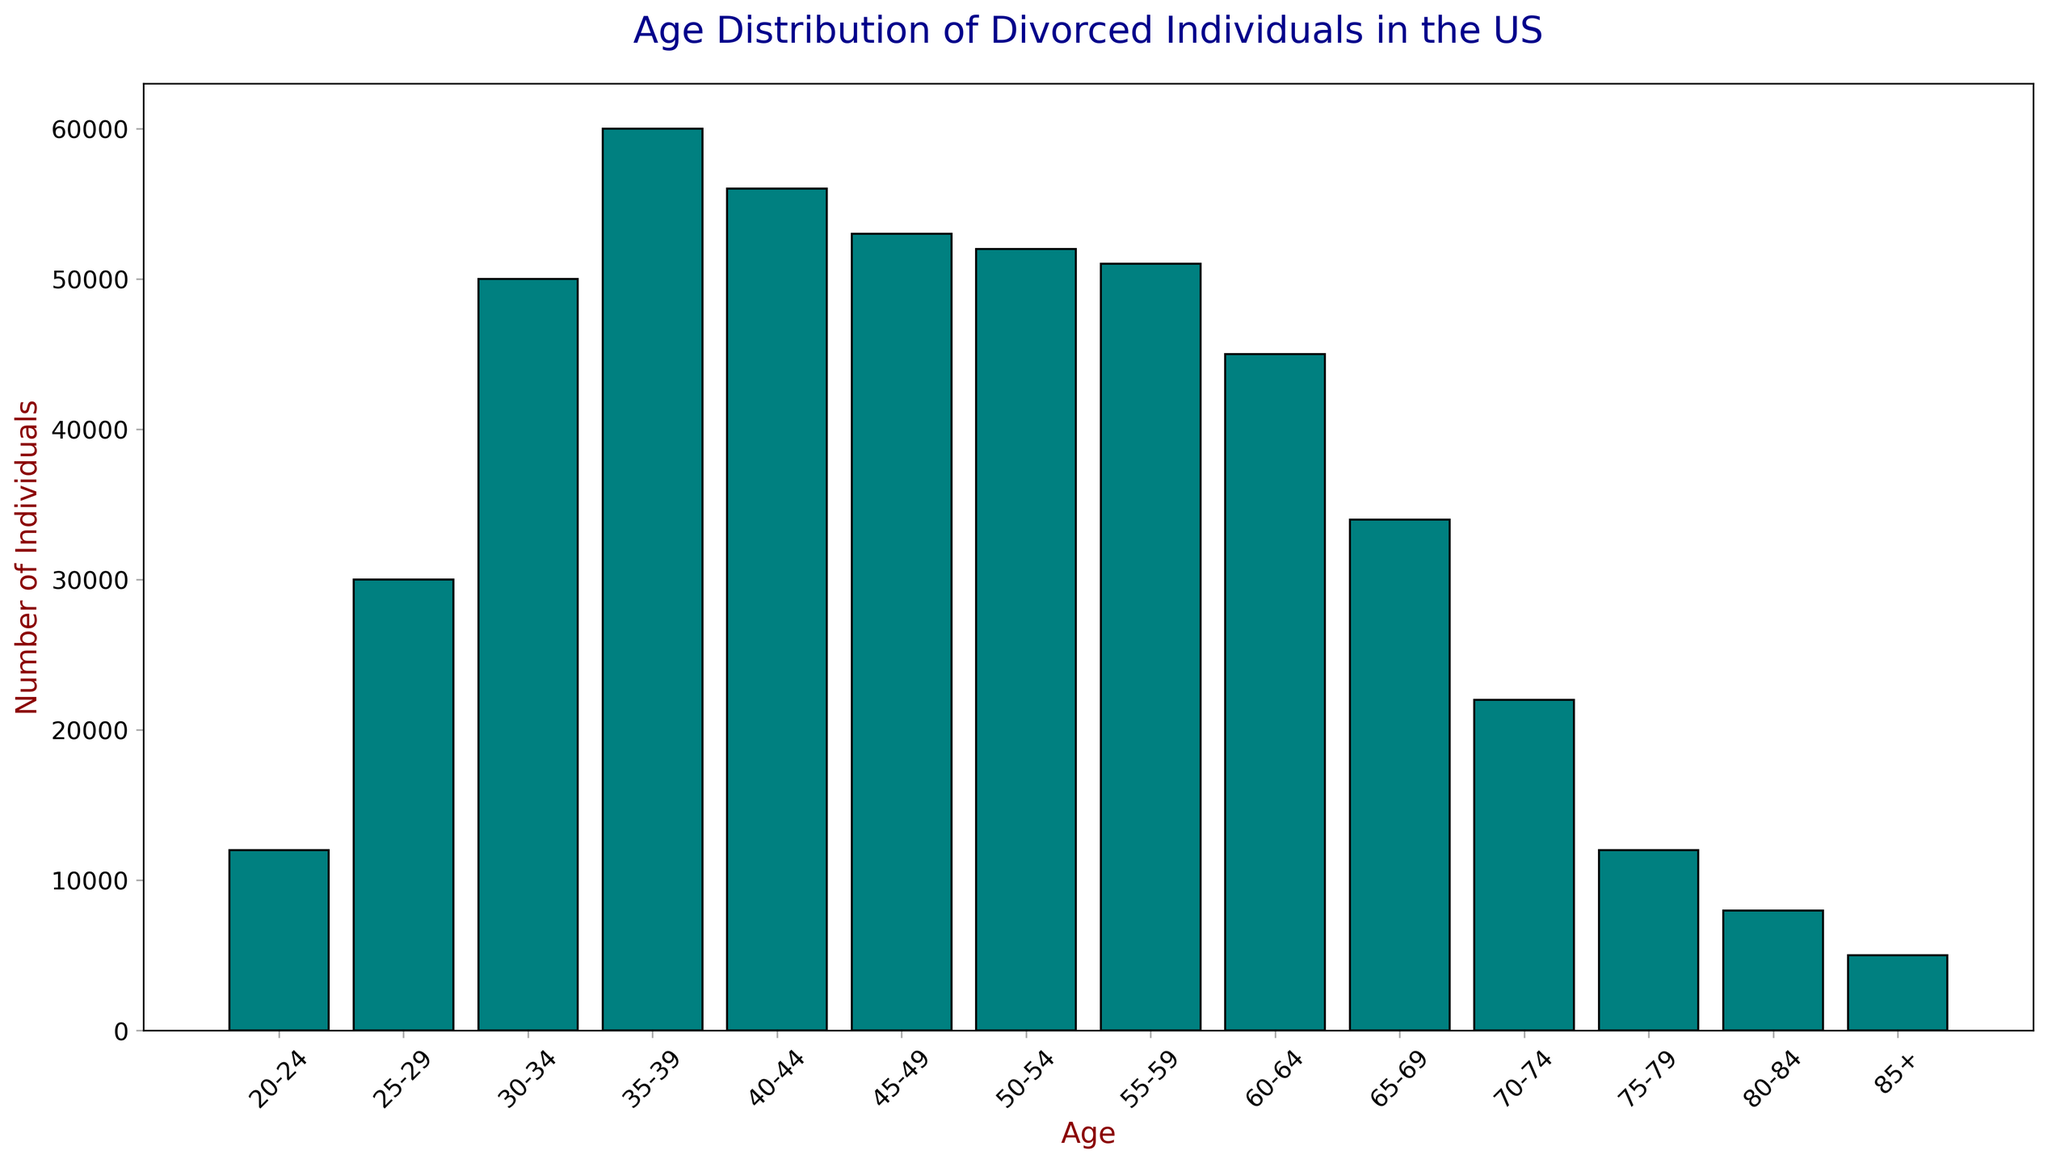What age group has the highest number of divorced individuals? The age group with the highest number of divorced individuals corresponds to the tallest bar in the histogram.
Answer: 35-39 Which age group has more divorced individuals, 45-49 or 40-44? To compare these two groups, look at the heights of the bars for the age groups 45-49 and 40-44. The bar for 40-44 is slightly taller than the one for 45-49.
Answer: 40-44 What is the total number of divorced individuals between the ages 30 and 39? To find the total, sum the counts for the age groups 30-34 and 35-39. These are 50,000 and 60,000, respectively. So, 50,000 + 60,000 = 110,000.
Answer: 110,000 How does the number of divorced individuals aged 60-64 compare with those aged 50-54? Look at the bars for age groups 60-64 and 50-54. The bar for age 50-54 is taller than the bar for age 60-64, indicating more individuals in the 50-54 range.
Answer: 50-54 What trend do you observe in the number of divorced individuals from age 20-24 to age 35-39? The number of divorced individuals increases steadily from age 20-24 to age 35-39, as indicated by progressively taller bars.
Answer: Increasing trend How many more divorced individuals are there in the age group 55-59 compared to 85+? Subtract the count of the 85+ group from the 55-59 group. For age 55-59, the count is 51,000, and for 85+, it is 5,000. Therefore, 51,000 - 5,000 = 46,000.
Answer: 46,000 Which groups have less than 20,000 divorced individuals? Identify the bars with a height corresponding to counts less than 20,000. These groups are 20-24, 75-79, 80-84, and 85+.
Answer: 20-24, 75-79, 80-84, 85+ What is the approximate average number of divorced individuals for the age groups 50-54, 55-59, and 60-64? Sum the counts of these groups and divide by three. Counts: 52,000 (50-54) + 51,000 (55-59) + 45,000 (60-64) = 148,000. Average = 148,000 / 3 = 49,333.
Answer: 49,333 